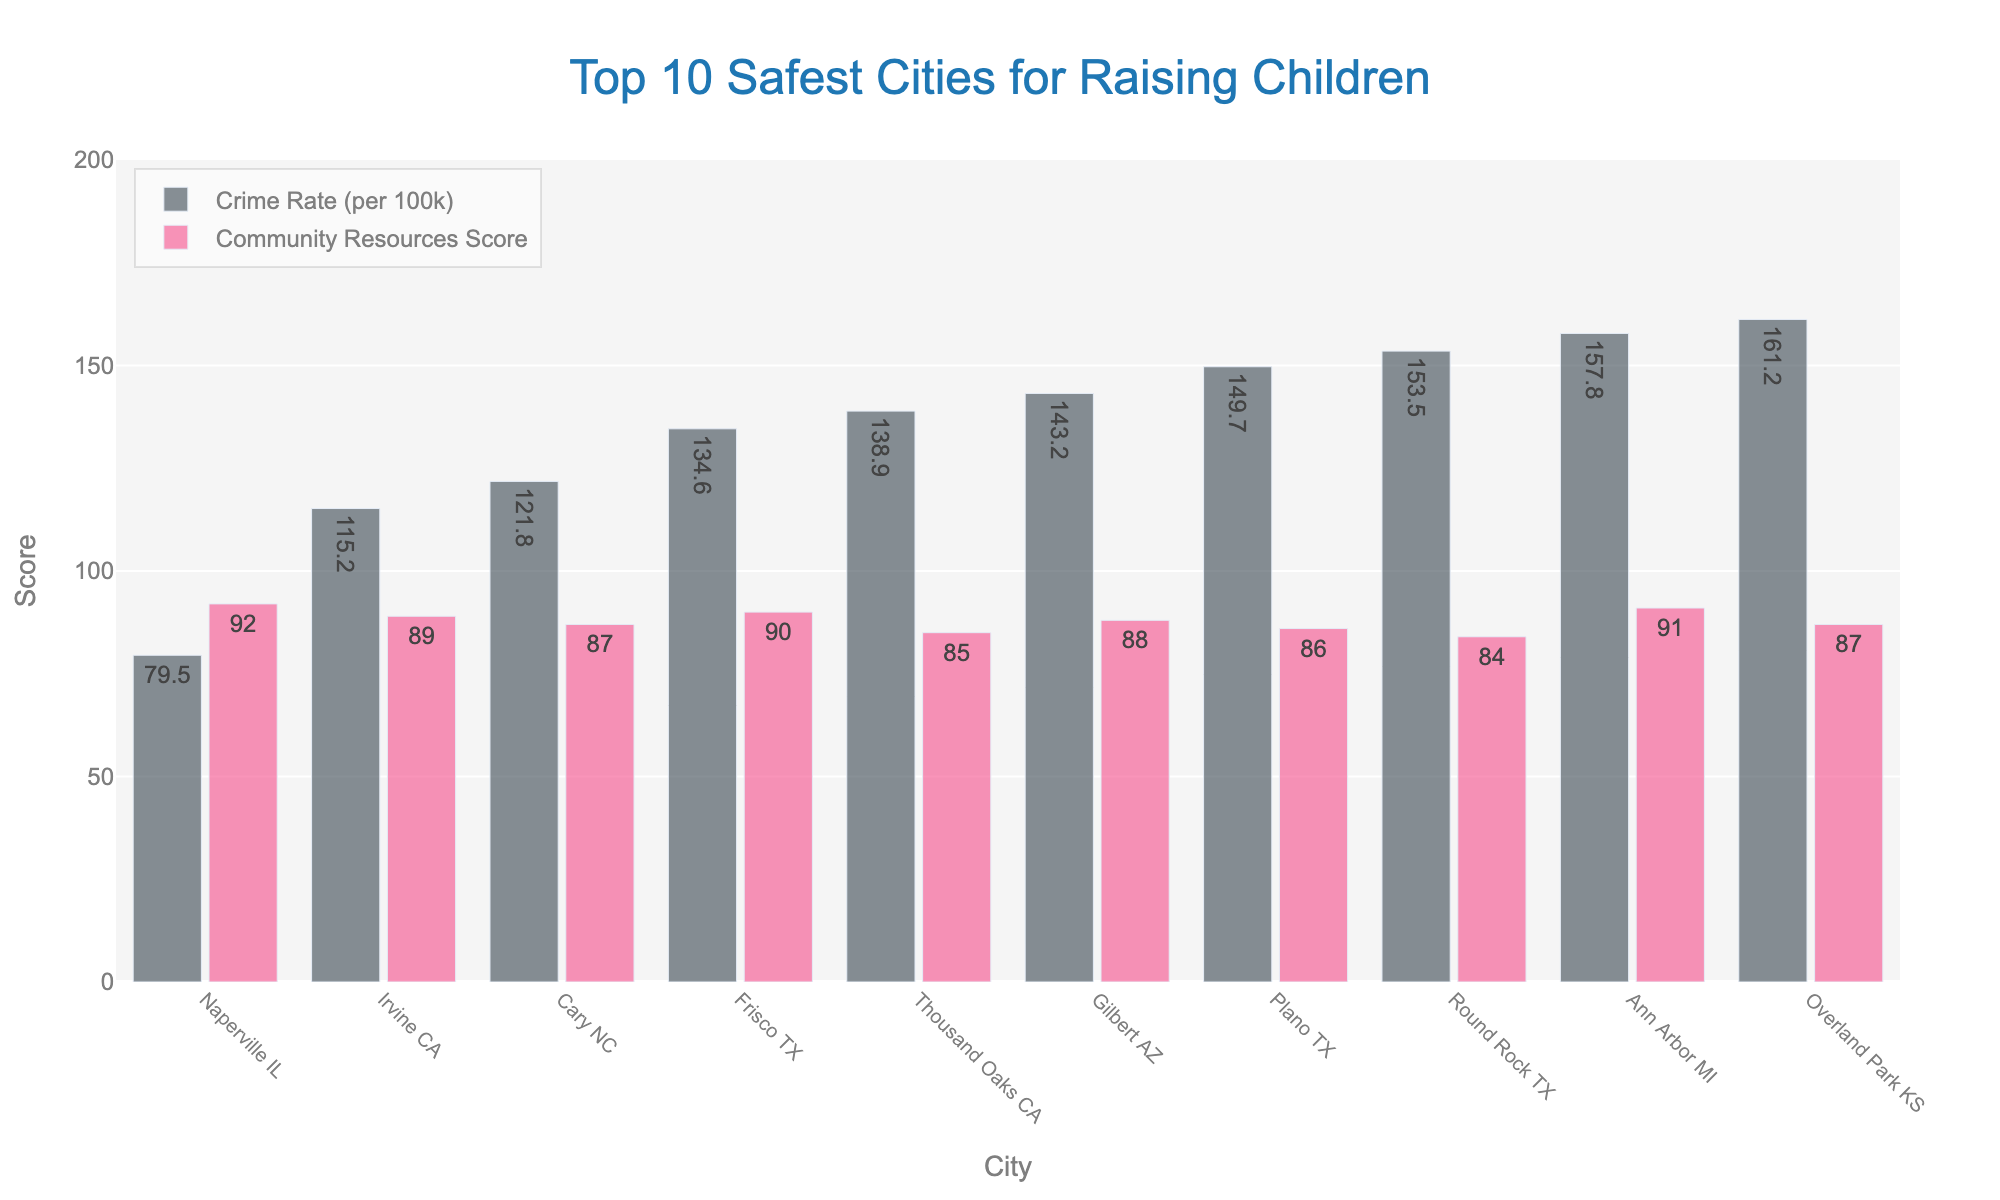What's the city with the lowest crime rate? By inspecting the height of the bars representing the "Crime Rate (per 100k)" for each city, we can identify the shortest bar. The shortest bar corresponds to Naperville IL.
Answer: Naperville IL Which city has the highest Community Resources Score and what's that score? Look for the tallest bar representing the "Community Resources Score" in the chart. The tallest bar for Community Resources Score is for Naperville IL, with a score of 92.
Answer: Naperville IL, 92 Compare the crime rates of Naperville IL and Overland Park KS. Which city is safer based on crime rate? Comparing the bars representing "Crime Rate (per 100k)" for Naperville IL (79.5) and Overland Park KS (161.2), Naperville IL has a significantly lower crime rate.
Answer: Naperville IL Sum the community resources scores of the cities in Texas. Identify the cities in Texas from the chart (Frisco, Plano, Round Rock) and sum their Community Resources Scores (90 + 86 + 84 = 260).
Answer: 260 What is the average crime rate of the top 3 cities with the lowest crime rates? Identify the top 3 cities with the lowest crime rates: Naperville IL (79.5), Irvine CA (115.2), Cary NC (121.8). Calculate the average: (79.5 + 115.2 + 121.8) / 3 = 105.5.
Answer: 105.5 Between Frisco TX and Ann Arbor MI, which city has a better community resource score and by what margin? Comparing the Community Resources Scores of Frisco TX (90) and Ann Arbor MI (91), Ann Arbor MI has a higher score by a margin of 91 - 90 = 1.
Answer: Ann Arbor MI, 1 What's the overall range of crime rates across these cities? Identify the minimum and maximum crime rates from the chart. The lowest is for Naperville IL (79.5) and the highest is for Overland Park KS (161.2). The range is 161.2 - 79.5 = 81.7.
Answer: 81.7 How many cities have a community resources score above 85? Count the cities with Community Resources Scores above 85 from the chart: Naperville IL (92), Irvine CA (89), Cary NC (87), Frisco TX (90), Gilbert AZ (88), Plano TX (86), Ann Arbor MI (91), Overland Park KS (87). Total is 8 cities.
Answer: 8 